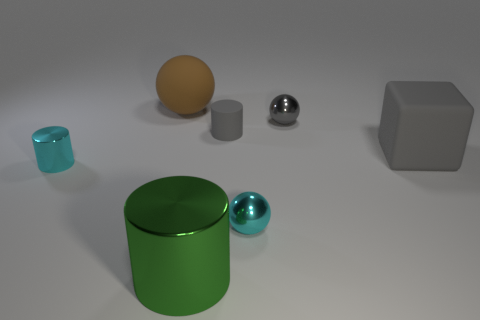What is the size of the cube that is the same color as the tiny matte cylinder?
Your answer should be very brief. Large. There is a metallic sphere behind the tiny metal thing that is left of the large brown thing; are there any big green cylinders that are behind it?
Provide a short and direct response. No. Are there any tiny gray rubber cylinders to the right of the large block?
Provide a succinct answer. No. There is a small cyan object right of the large brown sphere; how many tiny shiny objects are behind it?
Keep it short and to the point. 2. Does the brown rubber thing have the same size as the shiny cylinder that is on the right side of the large matte ball?
Give a very brief answer. Yes. Are there any other rubber things that have the same color as the small matte thing?
Give a very brief answer. Yes. There is a brown ball that is made of the same material as the gray block; what is its size?
Provide a succinct answer. Large. Are the large green thing and the gray ball made of the same material?
Your answer should be very brief. Yes. What color is the ball that is left of the gray matte thing to the left of the rubber thing on the right side of the tiny gray shiny sphere?
Your response must be concise. Brown. What is the shape of the green metallic thing?
Your answer should be compact. Cylinder. 